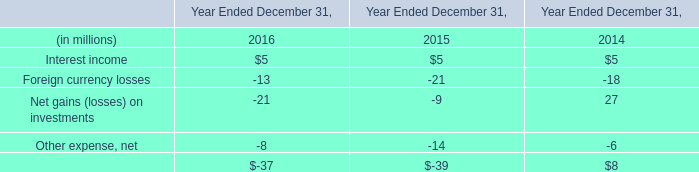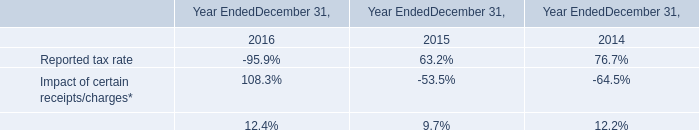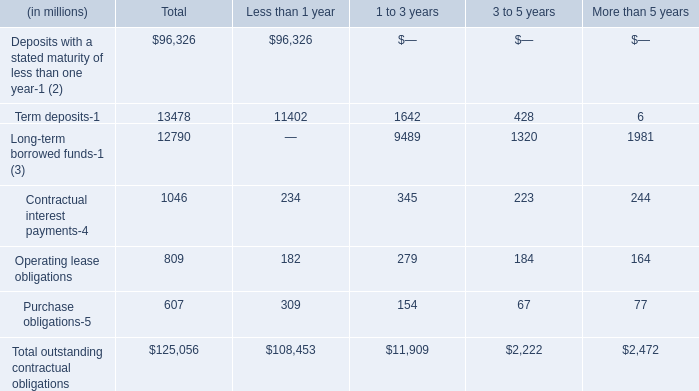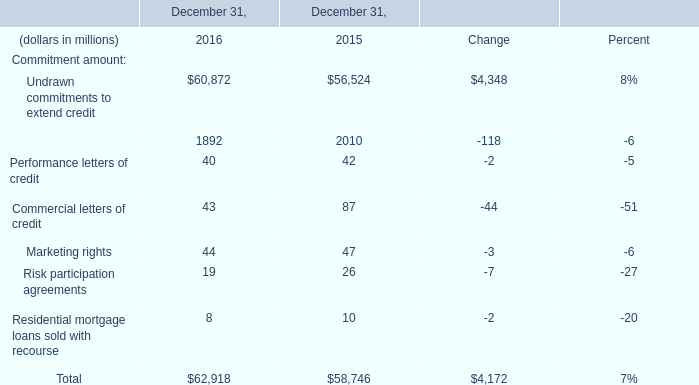What is the average amount of Term deposits of Less than 1 year, and Undrawn commitments to extend credit of December 31, 2016 ? 
Computations: ((11402.0 + 60872.0) / 2)
Answer: 36137.0. 